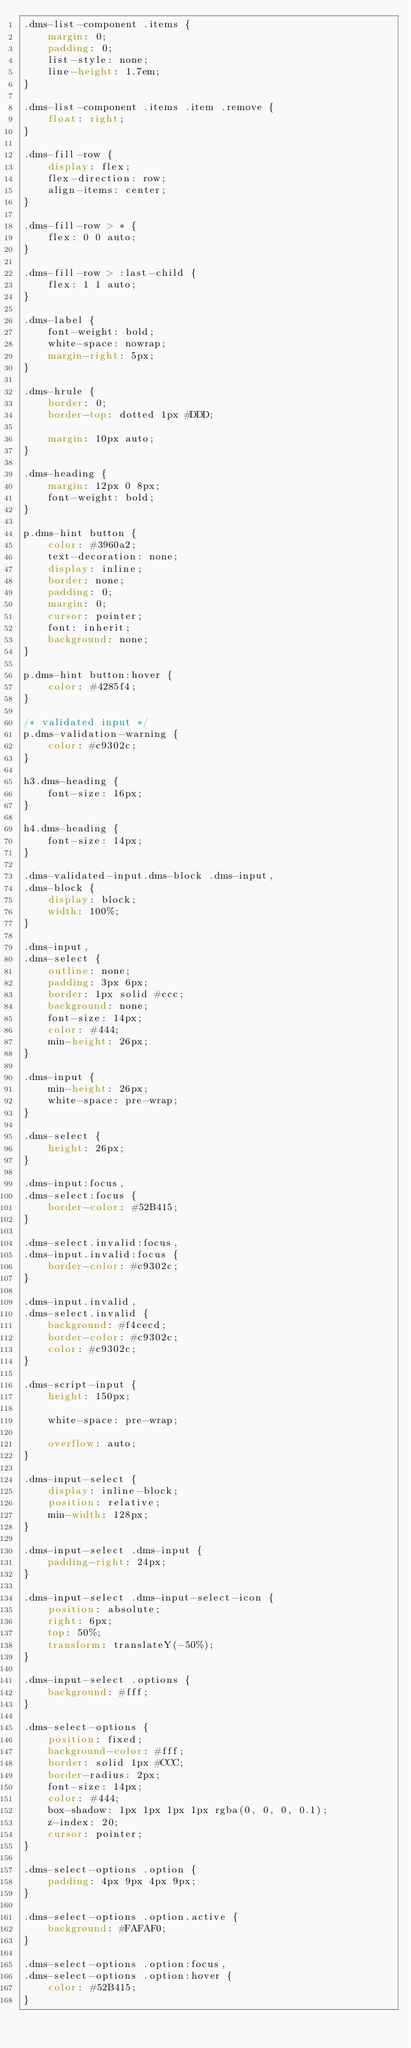<code> <loc_0><loc_0><loc_500><loc_500><_CSS_>.dms-list-component .items {
    margin: 0;
    padding: 0;
    list-style: none;
    line-height: 1.7em;
}

.dms-list-component .items .item .remove {
    float: right;
}

.dms-fill-row {
    display: flex;
    flex-direction: row;
    align-items: center;
}

.dms-fill-row > * {
    flex: 0 0 auto;
}

.dms-fill-row > :last-child {
    flex: 1 1 auto;
}

.dms-label {
    font-weight: bold;
    white-space: nowrap;
    margin-right: 5px;
}

.dms-hrule {
    border: 0;
    border-top: dotted 1px #DDD;

    margin: 10px auto;
}

.dms-heading {
    margin: 12px 0 8px;
    font-weight: bold;
}

p.dms-hint button {
    color: #3960a2;
    text-decoration: none;
    display: inline;
    border: none;
    padding: 0;
    margin: 0;
    cursor: pointer;
    font: inherit;
    background: none;
}

p.dms-hint button:hover {
    color: #4285f4;
}

/* validated input */
p.dms-validation-warning {
    color: #c9302c;
}

h3.dms-heading {
    font-size: 16px;
}

h4.dms-heading {
    font-size: 14px;
}

.dms-validated-input.dms-block .dms-input,
.dms-block {
    display: block;
    width: 100%;
}

.dms-input,
.dms-select {
    outline: none;
    padding: 3px 6px;
    border: 1px solid #ccc;
    background: none;
    font-size: 14px;
    color: #444;
    min-height: 26px;
}

.dms-input {
    min-height: 26px;
    white-space: pre-wrap;
}

.dms-select {
    height: 26px;
}

.dms-input:focus,
.dms-select:focus {
    border-color: #52B415;
}

.dms-select.invalid:focus,
.dms-input.invalid:focus {
    border-color: #c9302c;
}

.dms-input.invalid,
.dms-select.invalid {
    background: #f4cecd;
    border-color: #c9302c;
    color: #c9302c;
}

.dms-script-input {
    height: 150px;

    white-space: pre-wrap;

    overflow: auto;
}

.dms-input-select {
    display: inline-block;
    position: relative;
    min-width: 128px;
}

.dms-input-select .dms-input {
    padding-right: 24px;
}

.dms-input-select .dms-input-select-icon {
    position: absolute;
    right: 6px;
    top: 50%;
    transform: translateY(-50%);
}

.dms-input-select .options {
    background: #fff;
}

.dms-select-options {
    position: fixed;
    background-color: #fff;
    border: solid 1px #CCC;
    border-radius: 2px;
    font-size: 14px;
    color: #444;
    box-shadow: 1px 1px 1px 1px rgba(0, 0, 0, 0.1);
    z-index: 20;
    cursor: pointer;
}

.dms-select-options .option {
    padding: 4px 9px 4px 9px;
}

.dms-select-options .option.active {
    background: #FAFAF0;
}

.dms-select-options .option:focus,
.dms-select-options .option:hover {
    color: #52B415;
}
</code> 